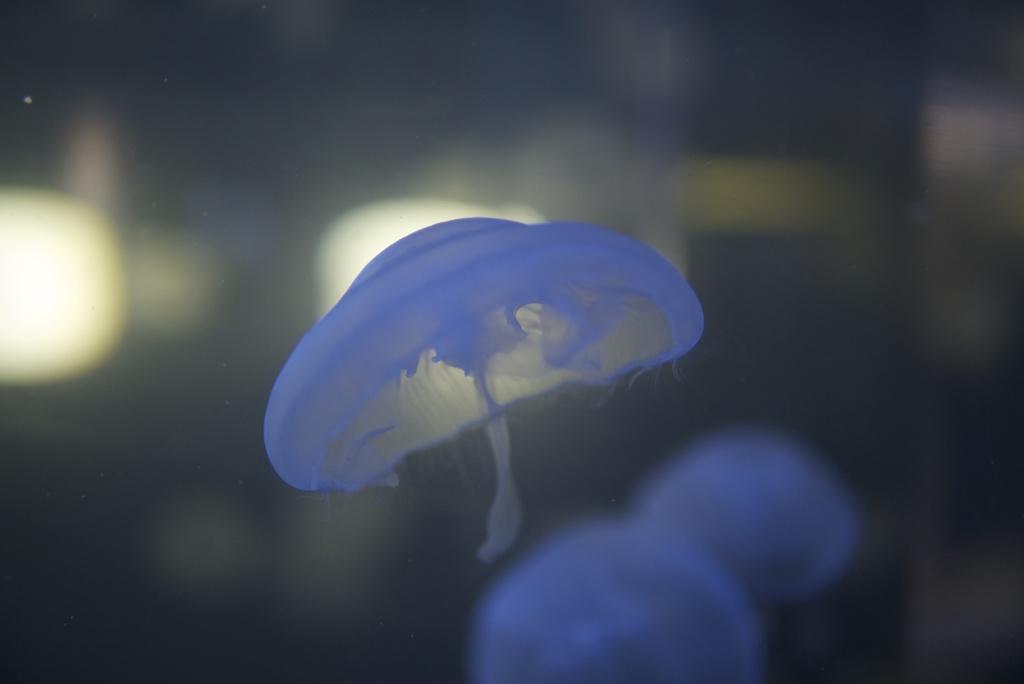Could you give a brief overview of what you see in this image? In this image I can see few blue colored jellyfish. Background is blurred. 